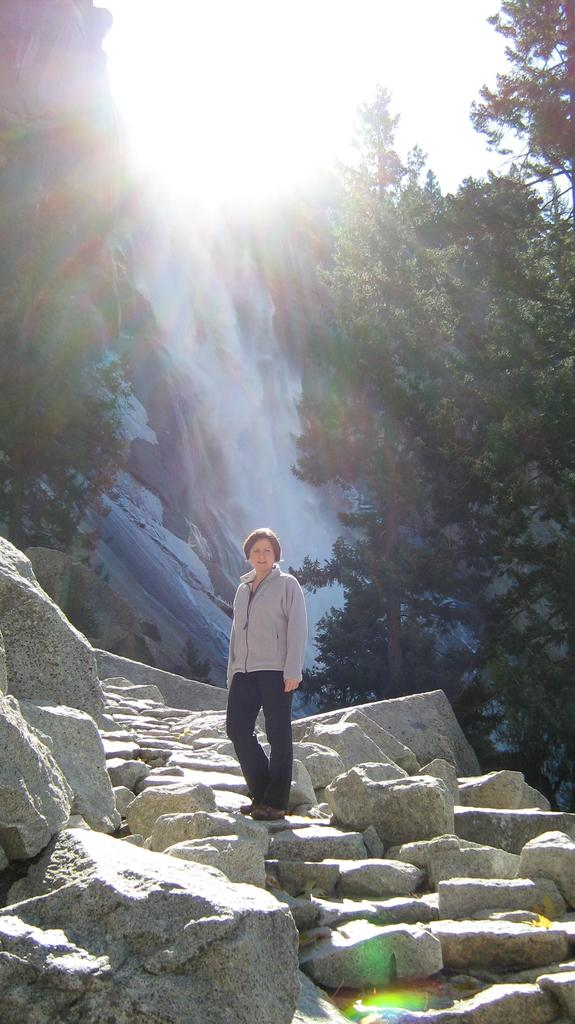What type of natural elements can be seen in the image? There are rocks and stones in the image. Where is the person located in the image? The person is standing in the middle of the image. What can be seen in the background of the image? There is a waterfall and green color trees in the background of the image. How many dogs are present in the image? There are no dogs present in the image. What type of park can be seen in the image? There is no park present in the image. 